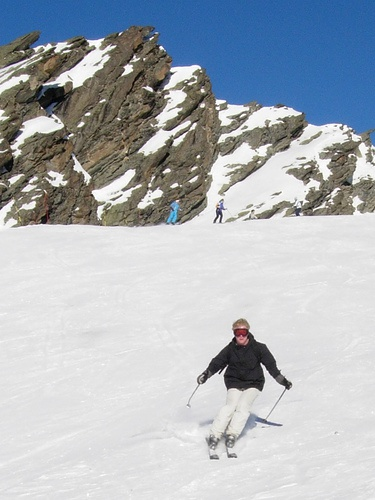Describe the objects in this image and their specific colors. I can see people in blue, black, lightgray, gray, and darkgray tones, skis in blue, darkgray, lightgray, and gray tones, people in blue, lightblue, gray, and darkgray tones, people in blue, gray, darkgray, and black tones, and people in blue, lightgray, gray, darkgray, and black tones in this image. 